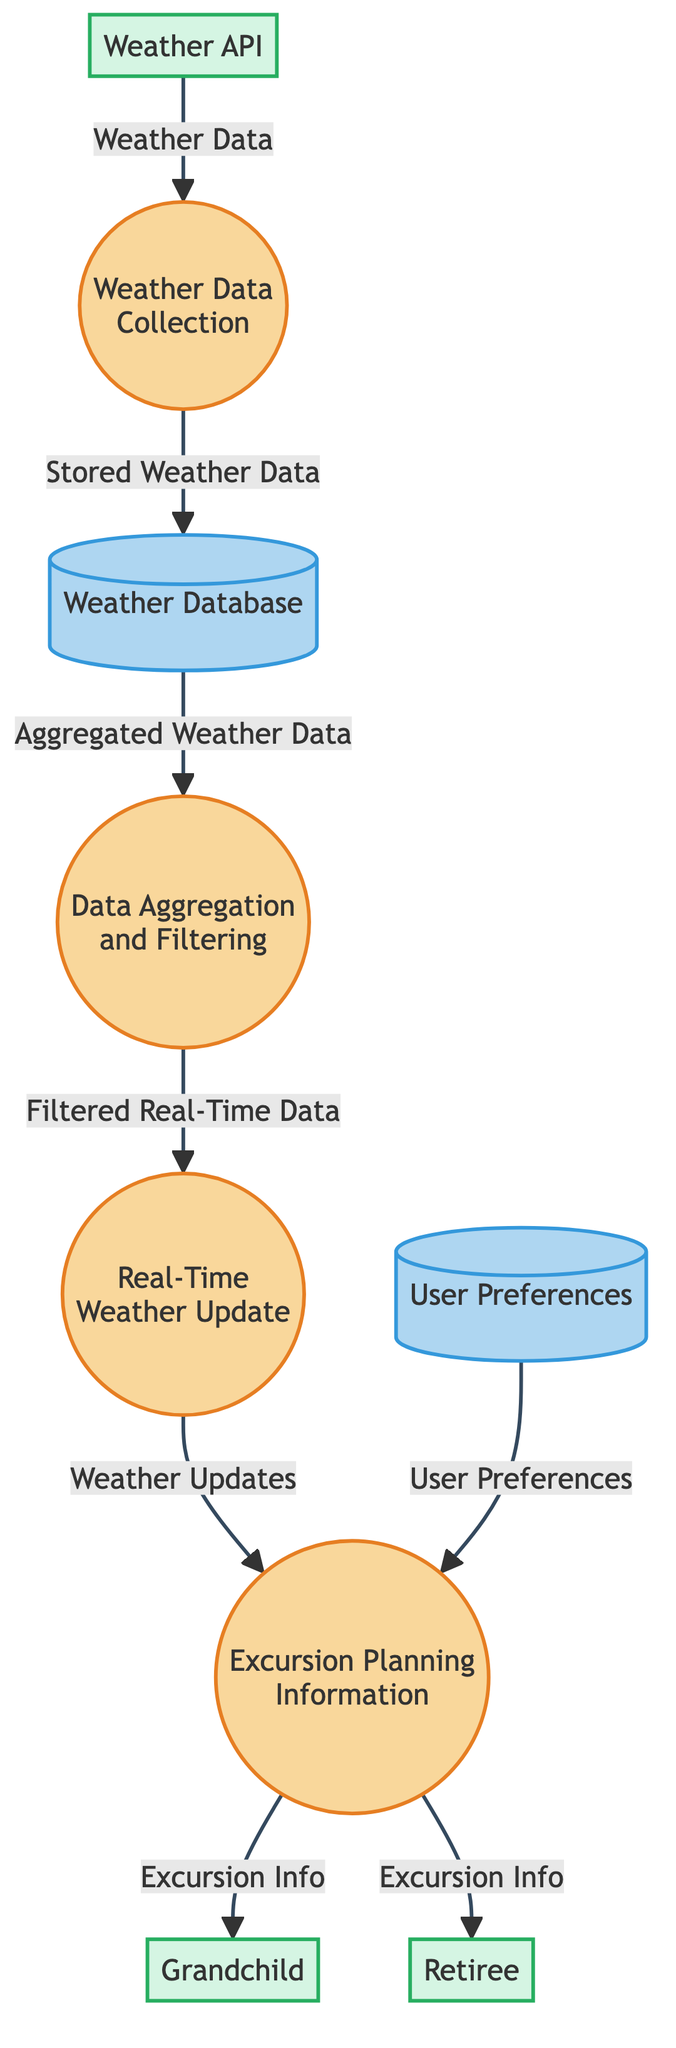What is the first process in the diagram? The first process is indicated with the ID "1". According to the description associated with process ID "1", it is labeled "Weather Data Collection".
Answer: Weather Data Collection How many data stores are represented in the diagram? The diagram shows two data stores: Weather Database and User Preferences. Counting these gives a total of two data stores.
Answer: 2 Which external entity provides weather data to the first process? The external entity that provides weather data is labeled "Weather API", as shown flowing into process ID "1".
Answer: Weather API What label connects the Weather Database to the Data Aggregation and Filtering process? The data flow from Weather Database to Data Aggregation and Filtering is labeled "Aggregated Weather Data". This indicates the type of information moving from one component to another.
Answer: Aggregated Weather Data What is the final output of the Excursion Planning Information process? The Excursion Planning Information process sends output to two external entities labeled "Grandchild" and "Retiree". Therefore, each entity receives "Excursion Info" as the final output.
Answer: Excursion Info Which process is responsible for filtering real-time data? The process responsible for filtering real-time data has the ID "2", which is labeled "Data Aggregation and Filtering".
Answer: Data Aggregation and Filtering What data flows into the Excursion Planning Information process besides User Preferences? In addition to User Preferences, the Excursion Planning Information process receives "Weather Updates" from the Real-Time Weather Update process identified as process ID "3".
Answer: Weather Updates How does the Weather Data Collection process interact with the Weather Database? The Weather Data Collection process stores weather data into the Weather Database, which is indicated by the arrow labeled "Stored Weather Data" flowing from process ID "1" to data store D1.
Answer: Stored Weather Data 